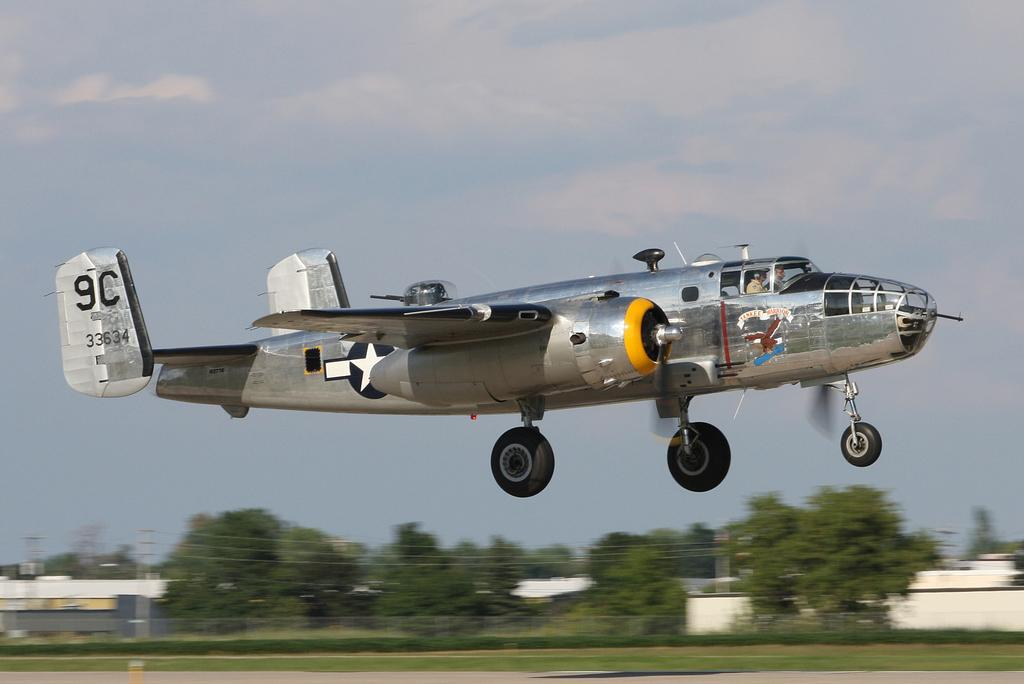What is the main subject of the image? The main subject of the image is an airplane flying in the sky. What can be seen in the background of the image? There are trees visible in the background of the image. What is the airplane's tendency to grip the clouds while flying in the image? There is no indication in the image that the airplane is gripping the clouds while flying. 